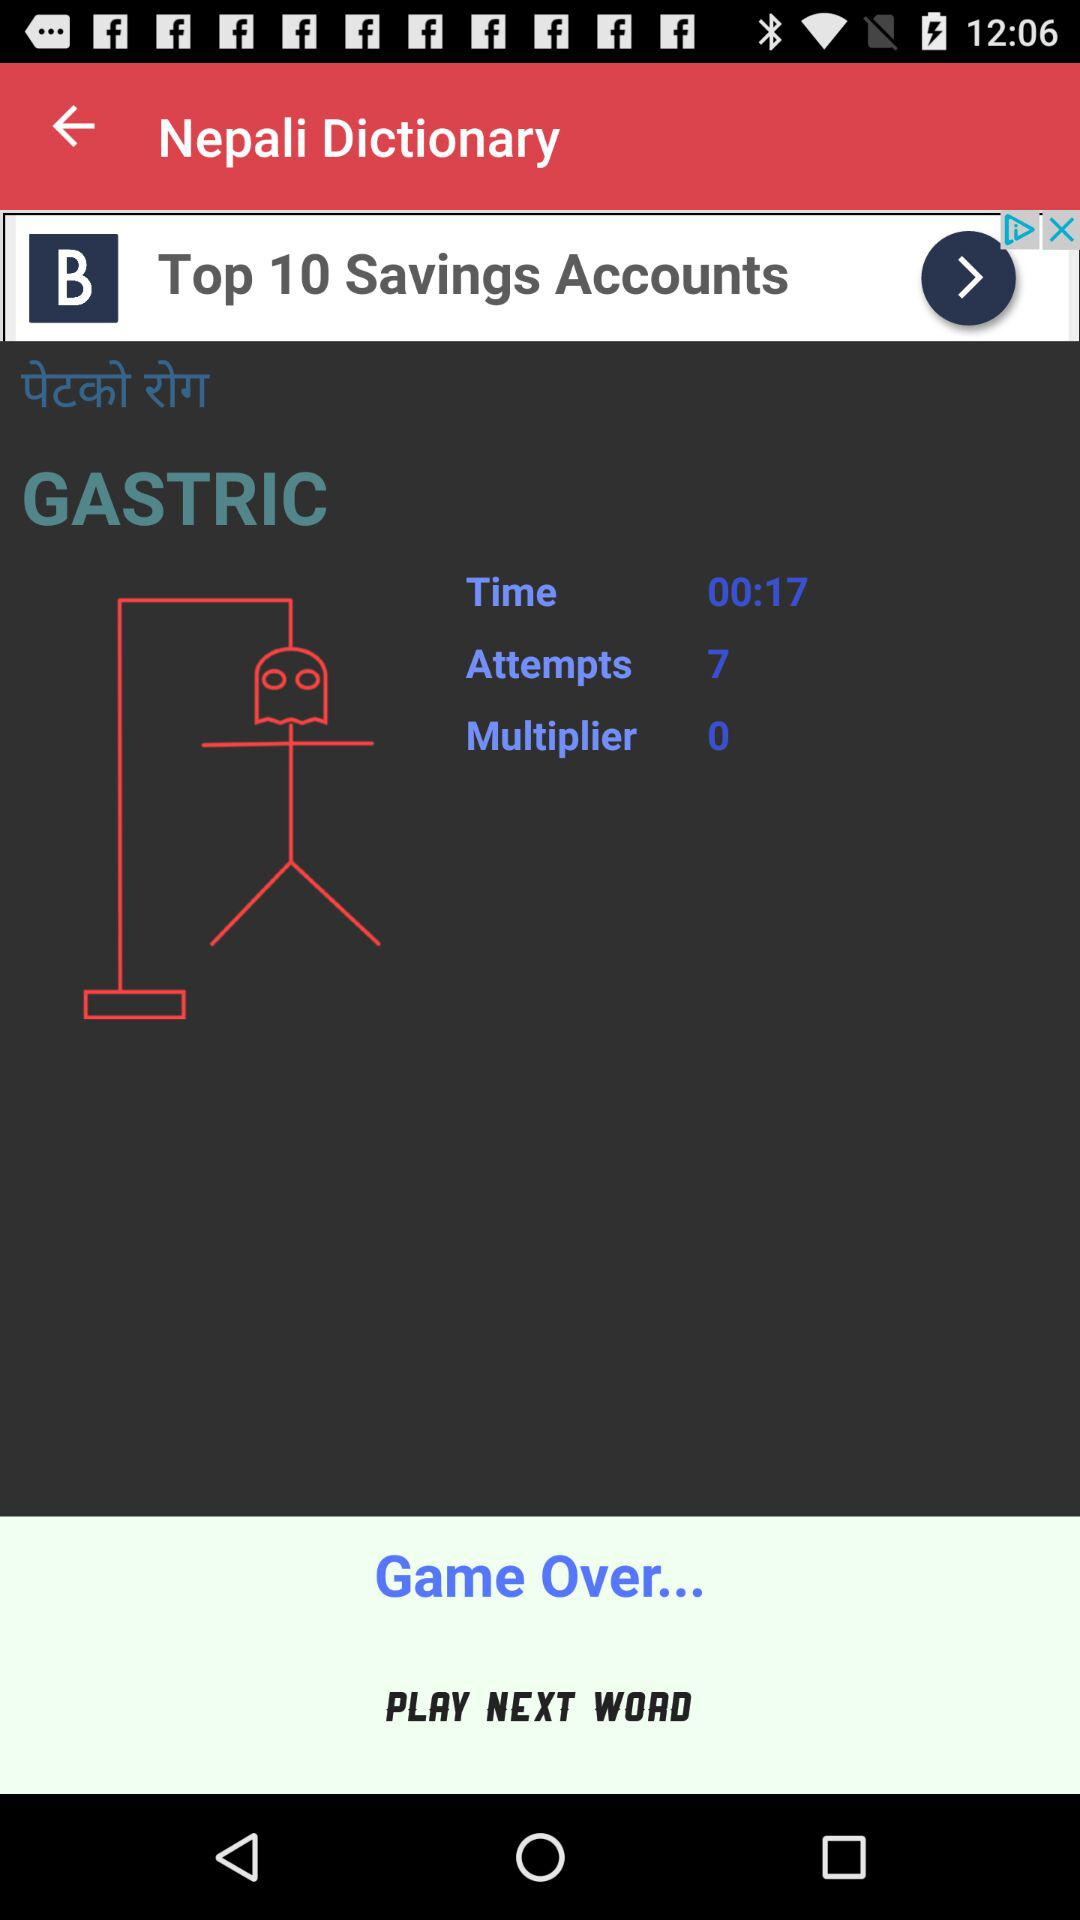When was the game played?
When the provided information is insufficient, respond with <no answer>. <no answer> 